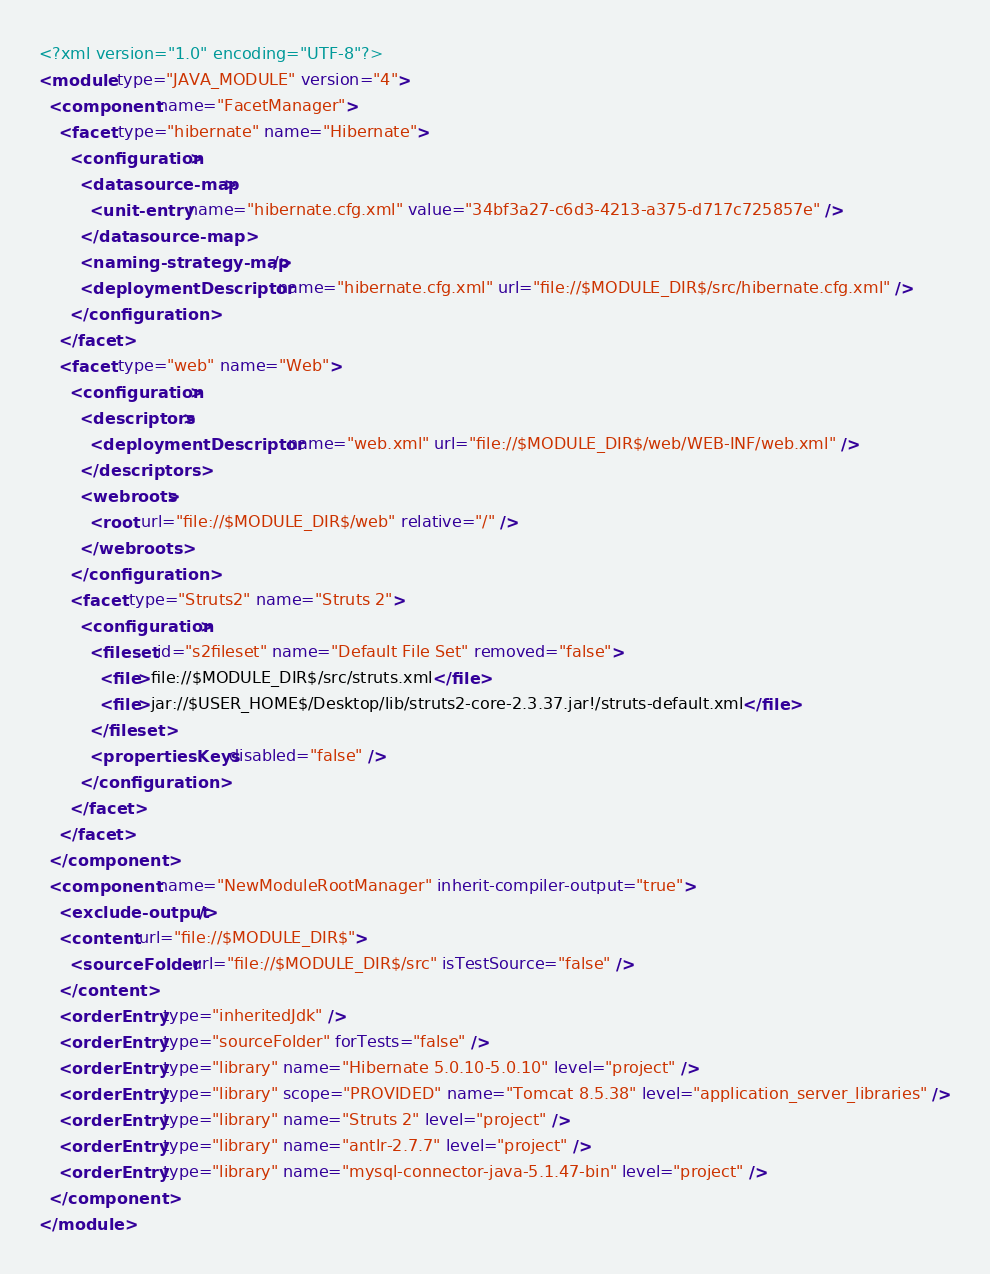<code> <loc_0><loc_0><loc_500><loc_500><_XML_><?xml version="1.0" encoding="UTF-8"?>
<module type="JAVA_MODULE" version="4">
  <component name="FacetManager">
    <facet type="hibernate" name="Hibernate">
      <configuration>
        <datasource-map>
          <unit-entry name="hibernate.cfg.xml" value="34bf3a27-c6d3-4213-a375-d717c725857e" />
        </datasource-map>
        <naming-strategy-map />
        <deploymentDescriptor name="hibernate.cfg.xml" url="file://$MODULE_DIR$/src/hibernate.cfg.xml" />
      </configuration>
    </facet>
    <facet type="web" name="Web">
      <configuration>
        <descriptors>
          <deploymentDescriptor name="web.xml" url="file://$MODULE_DIR$/web/WEB-INF/web.xml" />
        </descriptors>
        <webroots>
          <root url="file://$MODULE_DIR$/web" relative="/" />
        </webroots>
      </configuration>
      <facet type="Struts2" name="Struts 2">
        <configuration>
          <fileset id="s2fileset" name="Default File Set" removed="false">
            <file>file://$MODULE_DIR$/src/struts.xml</file>
            <file>jar://$USER_HOME$/Desktop/lib/struts2-core-2.3.37.jar!/struts-default.xml</file>
          </fileset>
          <propertiesKeys disabled="false" />
        </configuration>
      </facet>
    </facet>
  </component>
  <component name="NewModuleRootManager" inherit-compiler-output="true">
    <exclude-output />
    <content url="file://$MODULE_DIR$">
      <sourceFolder url="file://$MODULE_DIR$/src" isTestSource="false" />
    </content>
    <orderEntry type="inheritedJdk" />
    <orderEntry type="sourceFolder" forTests="false" />
    <orderEntry type="library" name="Hibernate 5.0.10-5.0.10" level="project" />
    <orderEntry type="library" scope="PROVIDED" name="Tomcat 8.5.38" level="application_server_libraries" />
    <orderEntry type="library" name="Struts 2" level="project" />
    <orderEntry type="library" name="antlr-2.7.7" level="project" />
    <orderEntry type="library" name="mysql-connector-java-5.1.47-bin" level="project" />
  </component>
</module></code> 